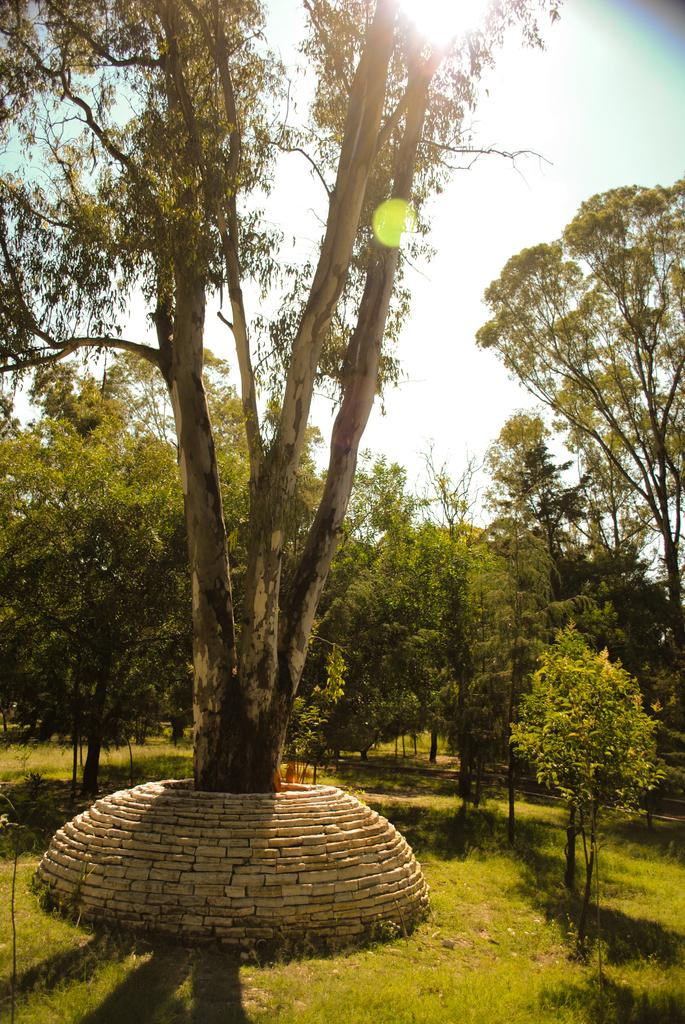What type of living organisms can be seen in the image? Plants and trees are visible in the image. What color are the plants and trees in the image? The plants and trees are green. What is visible in the background of the image? The sky is visible in the background of the image. What color is the sky in the image? The sky is white in the image. What type of cracker is being used to express regret in the image? There is no cracker or expression of regret present in the image. How does the image depict a good-bye scene? The image does not depict a good-bye scene; it features plants, trees, and a white sky. 